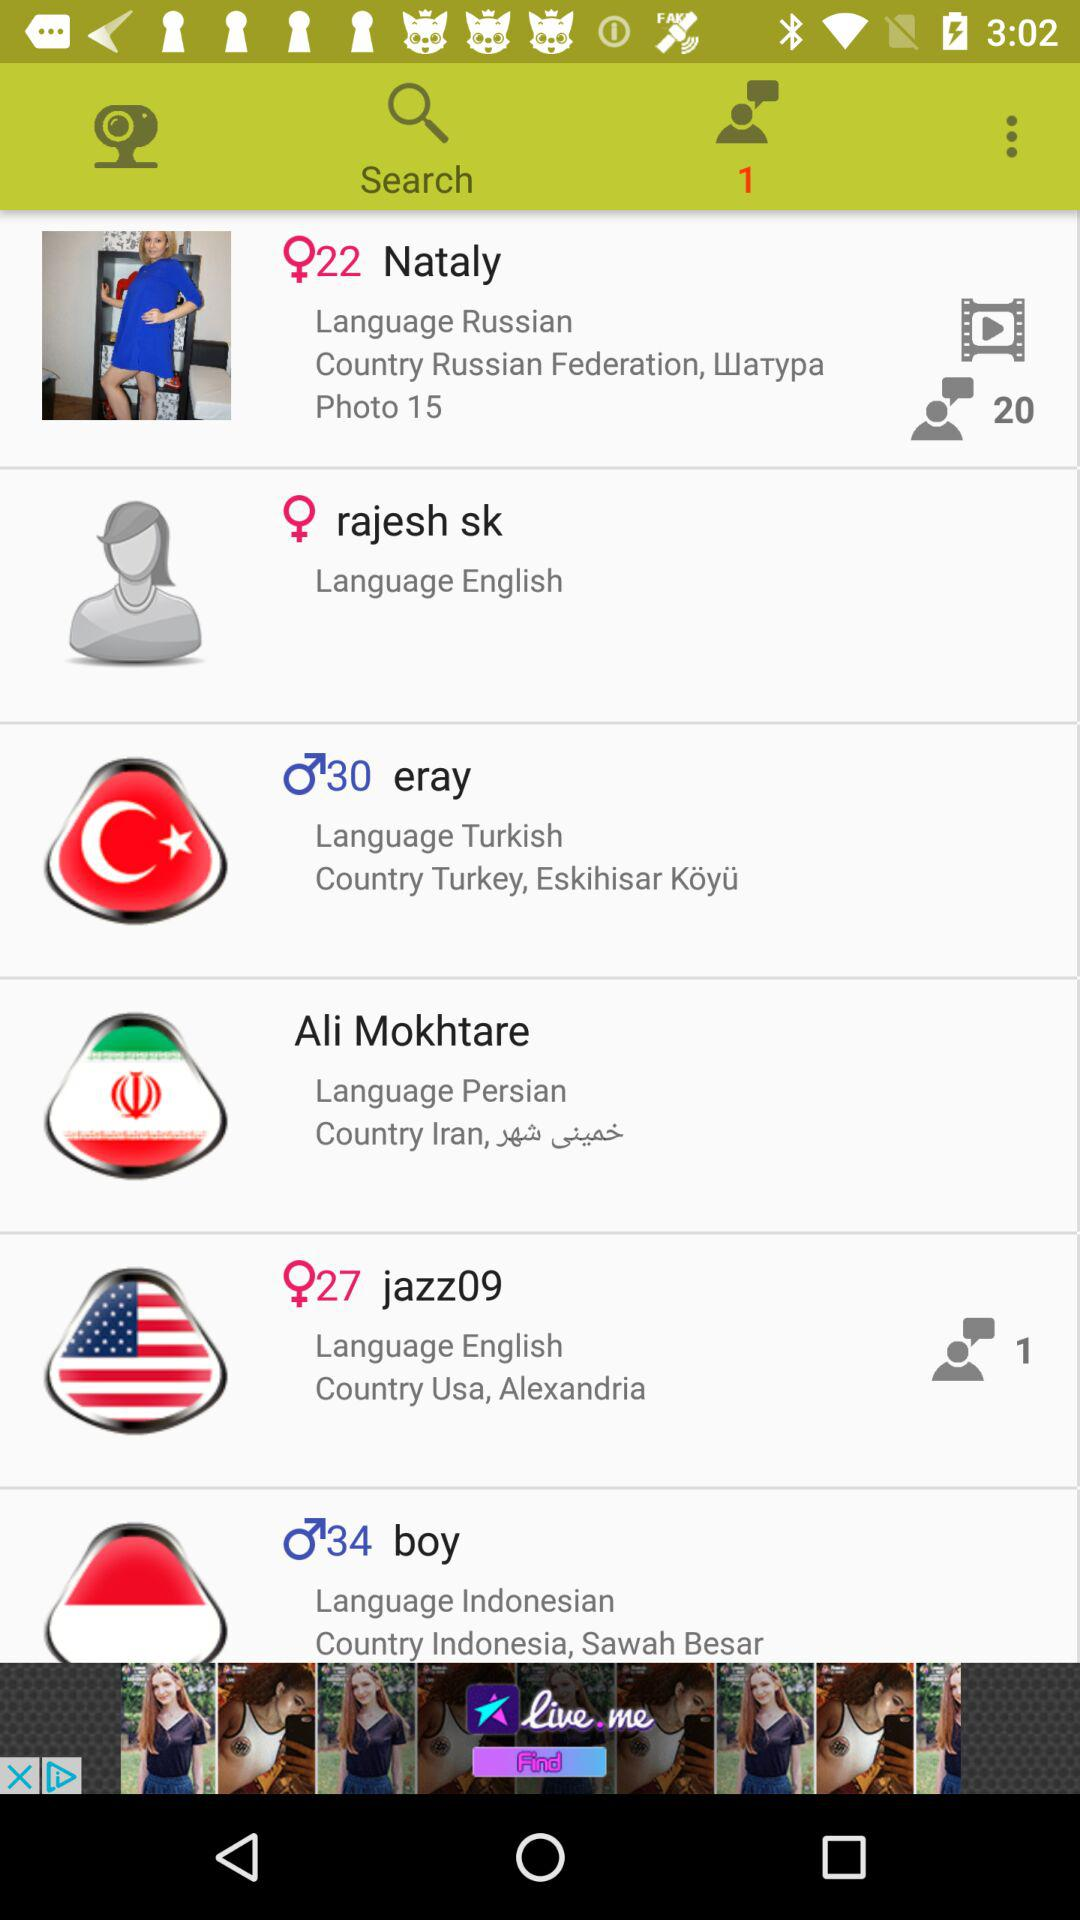Where does Nataly live? Nataly lives in Waтypa, Russian Federation. 